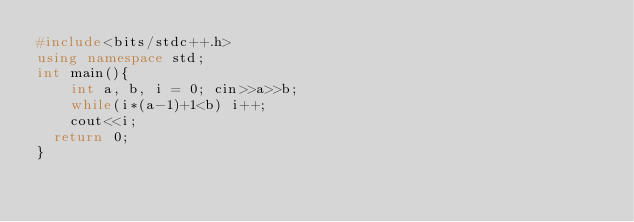Convert code to text. <code><loc_0><loc_0><loc_500><loc_500><_C++_>#include<bits/stdc++.h>
using namespace std;
int main(){
	int a, b, i = 0; cin>>a>>b;
	while(i*(a-1)+1<b) i++;
    cout<<i;	
  return 0;
}
</code> 